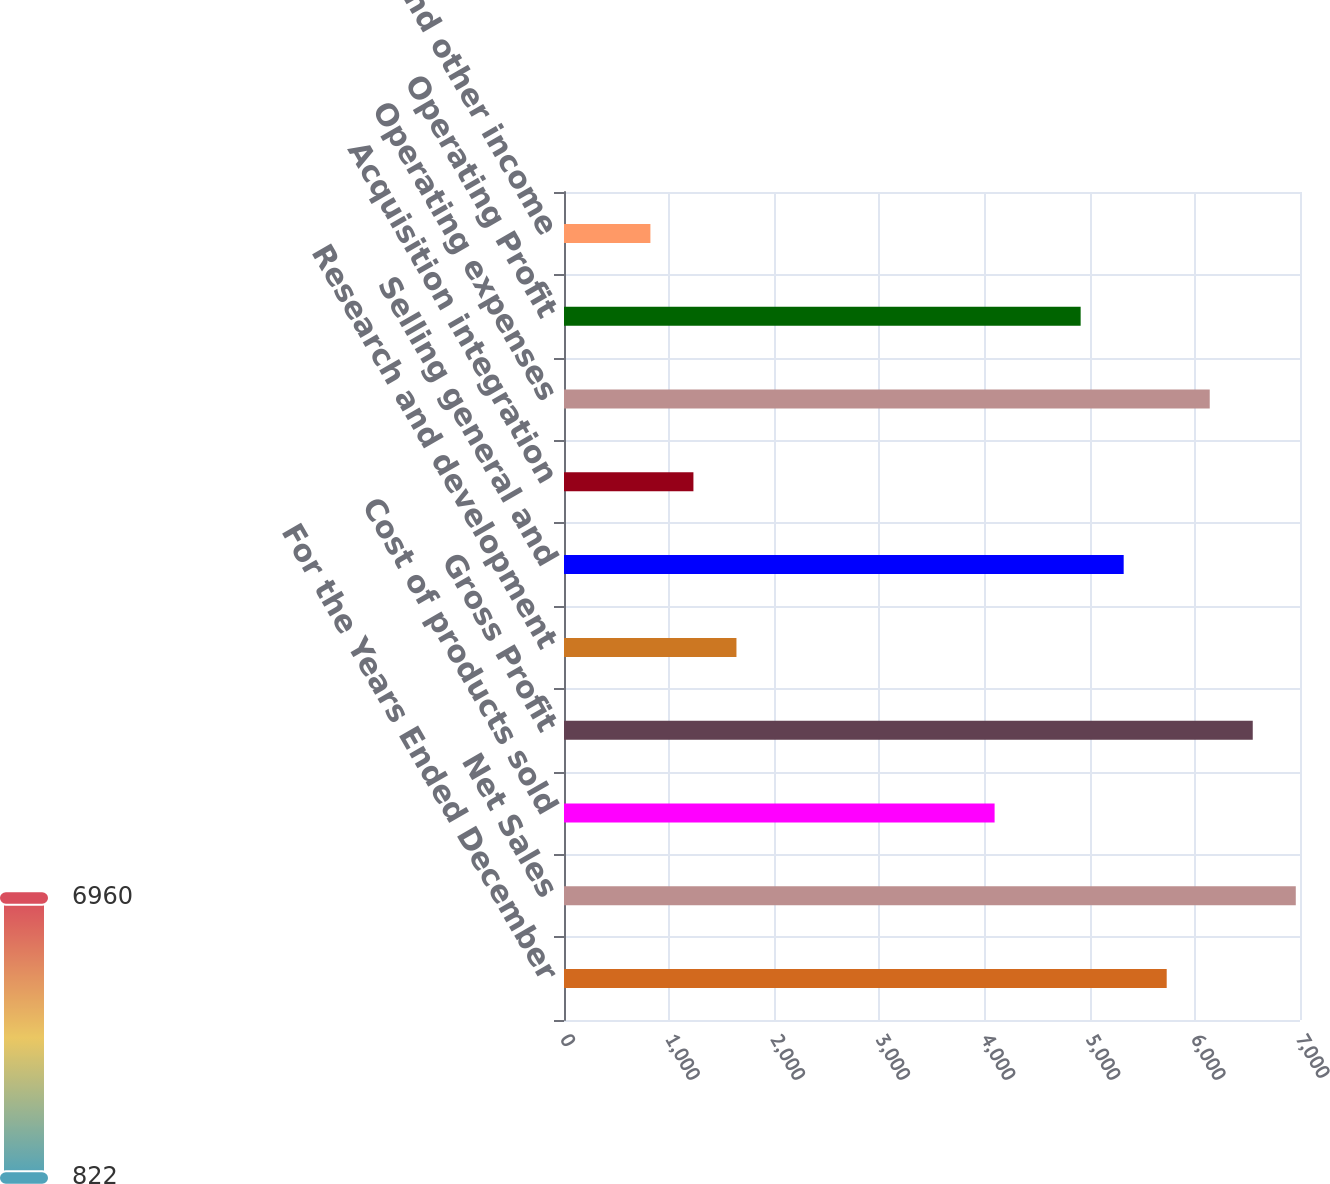Convert chart. <chart><loc_0><loc_0><loc_500><loc_500><bar_chart><fcel>For the Years Ended December<fcel>Net Sales<fcel>Cost of products sold<fcel>Gross Profit<fcel>Research and development<fcel>Selling general and<fcel>Acquisition integration<fcel>Operating expenses<fcel>Operating Profit<fcel>Interest and other income<nl><fcel>5732.26<fcel>6959.89<fcel>4095.42<fcel>6550.68<fcel>1640.16<fcel>5323.05<fcel>1230.95<fcel>6141.47<fcel>4913.84<fcel>821.74<nl></chart> 